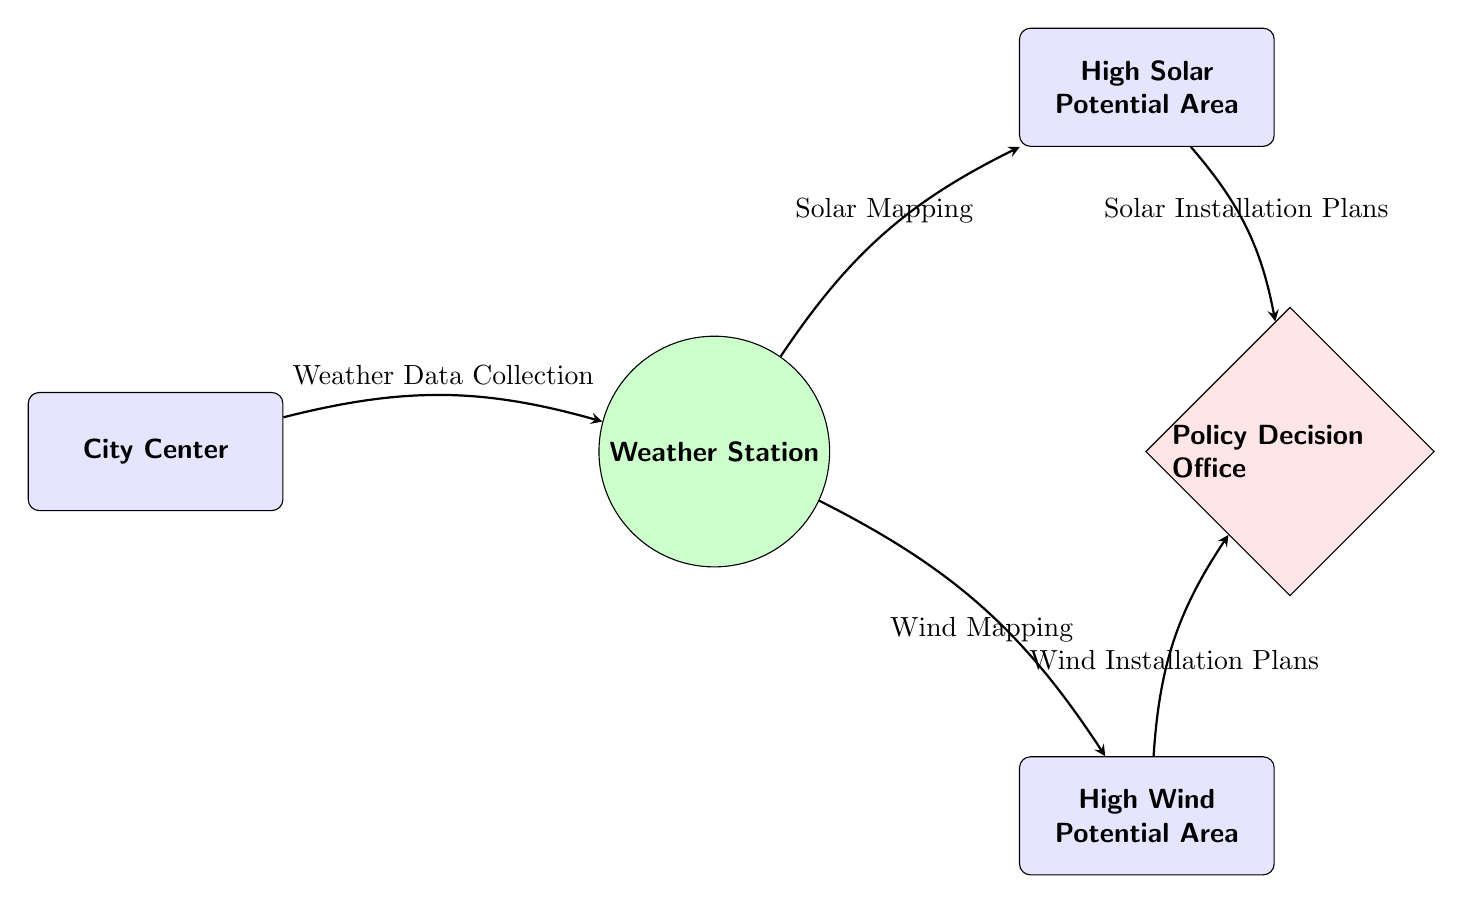What is the first node in the diagram? The diagram starts with the node labeled "City Center," which is the initial point where the process begins.
Answer: City Center How many potential energy areas are represented in the diagram? There are two potential energy areas shown, labeled "High Solar Potential Area" and "High Wind Potential Area," indicating the locations for solar and wind installations.
Answer: 2 Which node receives weather data collection? The "Weather Station" node is where the weather data is collected, as indicated by the arrow coming from the "City Center."
Answer: Weather Station What mapping is conducted after weather data collection? After collecting weather data, "Solar Mapping" is conducted, which connects the "Weather Station" to the "High Solar Potential Area."
Answer: Solar Mapping What is the final output from both energy potential areas? The final outputs from the "High Solar Potential Area" and "High Wind Potential Area" lead to "Solar Installation Plans" and "Wind Installation Plans," respectively, which are necessary for decision-making.
Answer: Solar Installation Plans and Wind Installation Plans What is the relationship between the weather station and the policy decision office? The "Weather Station" provides mapping information (both solar and wind) to the "Policy Decision Office," which makes decisions based on that information.
Answer: Mapping information In which direction do the arrows point to show the flow of information related to wind mapping? The arrows point downward from the "Weather Station" to the "High Wind Potential Area" and then to the "Policy Decision Office," indicating the flow of information for wind mapping.
Answer: Downward What color represents the High Solar Potential Area in the diagram? The "High Solar Potential Area" is represented in light blue, indicating its categorization as a renewable energy zone with strong solar potential.
Answer: Light blue What shape is used to represent the policy decision office? The "Policy Decision Office" is represented by a diamond shape, which distinguishes it from the other areas and facilities in the diagram.
Answer: Diamond 